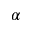<formula> <loc_0><loc_0><loc_500><loc_500>\alpha</formula> 